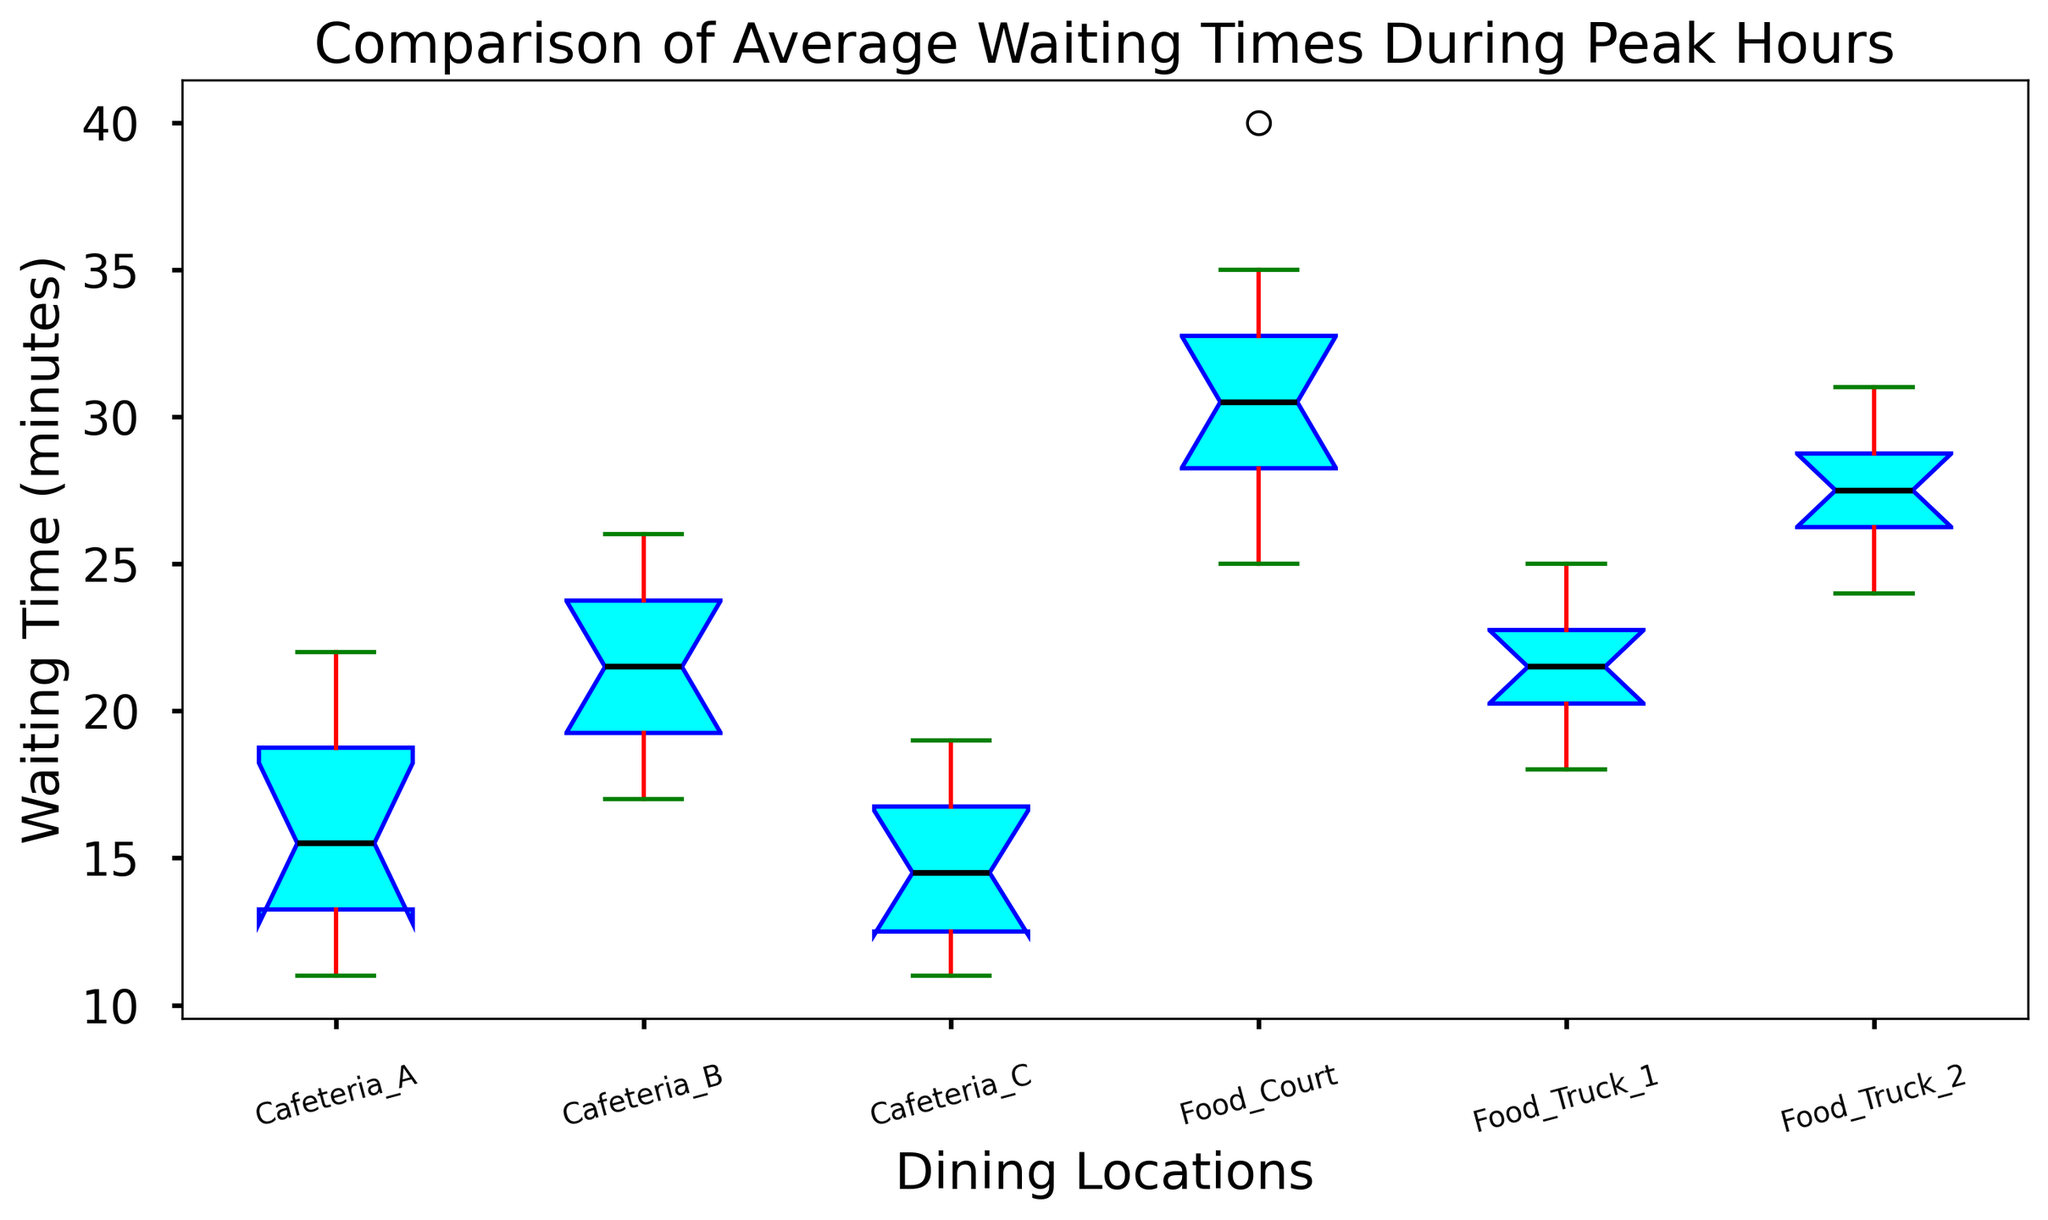What is the median waiting time for Cafeteria A? The median is shown as a horizontal line inside the box for Cafeteria A.
Answer: 15 Which dining location has the highest median waiting time? The black line inside each box represents the median; compare them to find the highest. The Food Court's black line is the highest.
Answer: Food Court What is the interquartile range (IQR) for Cafeteria C? The IQR is the difference between the third quartile (top edge of the box) and the first quartile (bottom edge of the box) for Cafeteria C.
Answer: 4 (16 - 12) Which dining location has the widest spread of waiting times? The spread is indicated by the distance between the top and bottom whiskers of each box plot. Food Court has the widest spread.
Answer: Food Court How does the median waiting time of Food Truck 1 compare to that of Food Truck 2? Compare the median lines in both boxes. Food Truck 2's median is slightly higher than Food Truck 1's.
Answer: Food Truck 2's median is slightly higher Which location has the smallest maximum waiting time amongst the dining options? Look at the top whiskers of each location; the smallest top whisker indicates the smallest maximum. Cafeteria C has the shortest top whisker.
Answer: Cafeteria C What is the range of waiting times for Food Truck 2? The range is the difference between the max (top whisker) and the min (bottom whisker) waiting times for Food Truck 2.
Answer: 7 (31 - 24) How do the variability in waiting times of Cafeteria B and Cafeteria C compare? Variability can be assessed by the range and IQR. Cafeteria B has a wider box and whisker range compared to Cafeteria C.
Answer: Cafeteria B has higher variability Which dining location has the most consistent (least variable) waiting times? The location with the shortest box and whiskers represents least variability.
Answer: Cafeteria C Is there any location where the median waiting time is above the upper quartile of Cafeteria A? Upper quartile of Cafeteria A is the top of its box. Compare the median lines of other locations to this value. Food Court's median is above Cafeteria A's upper quartile.
Answer: Yes, Food Court 